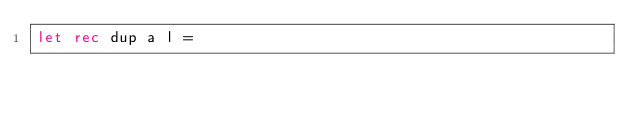Convert code to text. <code><loc_0><loc_0><loc_500><loc_500><_OCaml_>let rec dup a l =</code> 